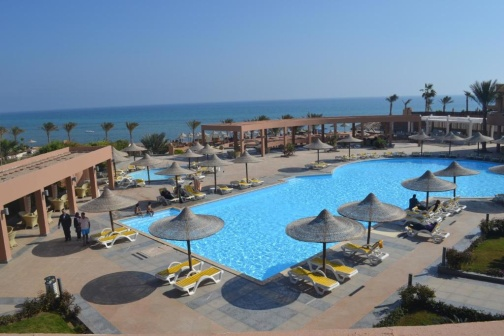Imagine a day at this resort; what activities might you engage in? Imagine waking up to the sound of gentle waves crashing in the distance. You step out onto your balcony to take in the stunning ocean view before heading down to the pool area. After a refreshing dip in the sparkling blue pool, you relax on a lounge chair, sipping a tropical cocktail under the shade of a thatched umbrella. Following a delicious breakfast at a nearby open-air restaurant, you stroll to the beach for some sunbathing and perhaps a bit of beach volleyball. As the afternoon heat intensifies, you retreat to the spa for a rejuvenating massage, followed by a leisurely swim. Dinner offers a culinary adventure at a fine-dining restaurant, enjoyed al fresco as you take in the breathtaking sunset over the ocean. What could be the potential history or background of this place? Imagine and describe. This resort perhaps started as a hidden gem, known only to a select few travelers. Over the years, it evolved from a small, family-run guesthouse into an expansive luxury destination. The pink building, now the main hub, could have once been an elegant colonial mansion, lovingly restored and expanded. The palm trees, standing tall and proud, might have been planted by the original owners as a symbol of hope and growth. Each upgrade to the resort was made with a commitment to preserving its serene ambiance while integrating modern comforts. Today, the resort's history is reflected in its meticulous design, blending tradition with luxury. 